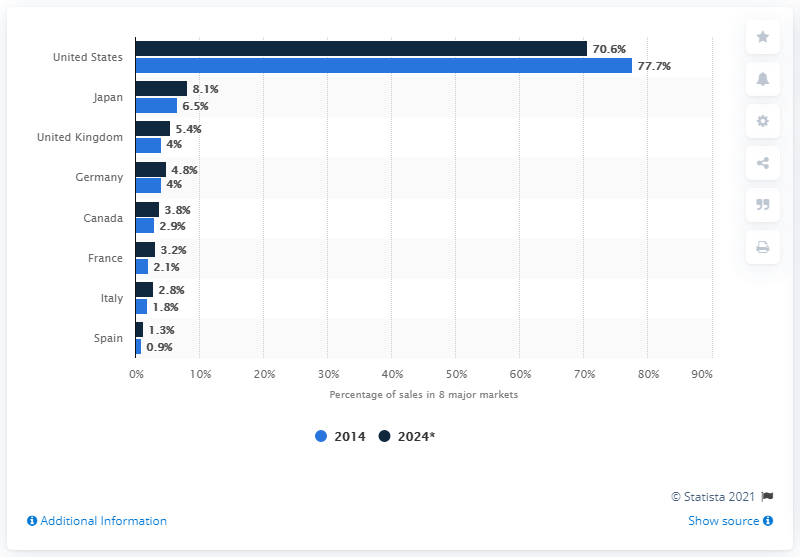Indicate a few pertinent items in this graphic. According to data from 2014, Canada accounted for approximately 2.9% of the total sales among the eight major pharmaceutical markets. 